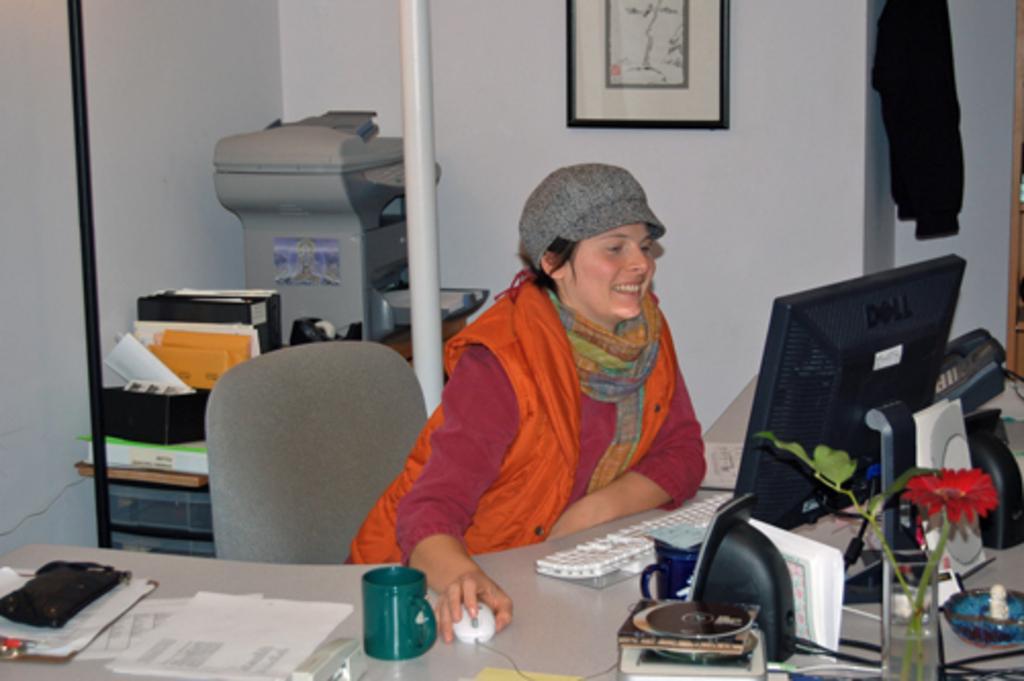Please provide a concise description of this image. This is a picture of a lady sitting on the chair in front of a desk and on the desk we have a laptop,cup and a small plant and also behind her there is a printer and some papers on the desk. 